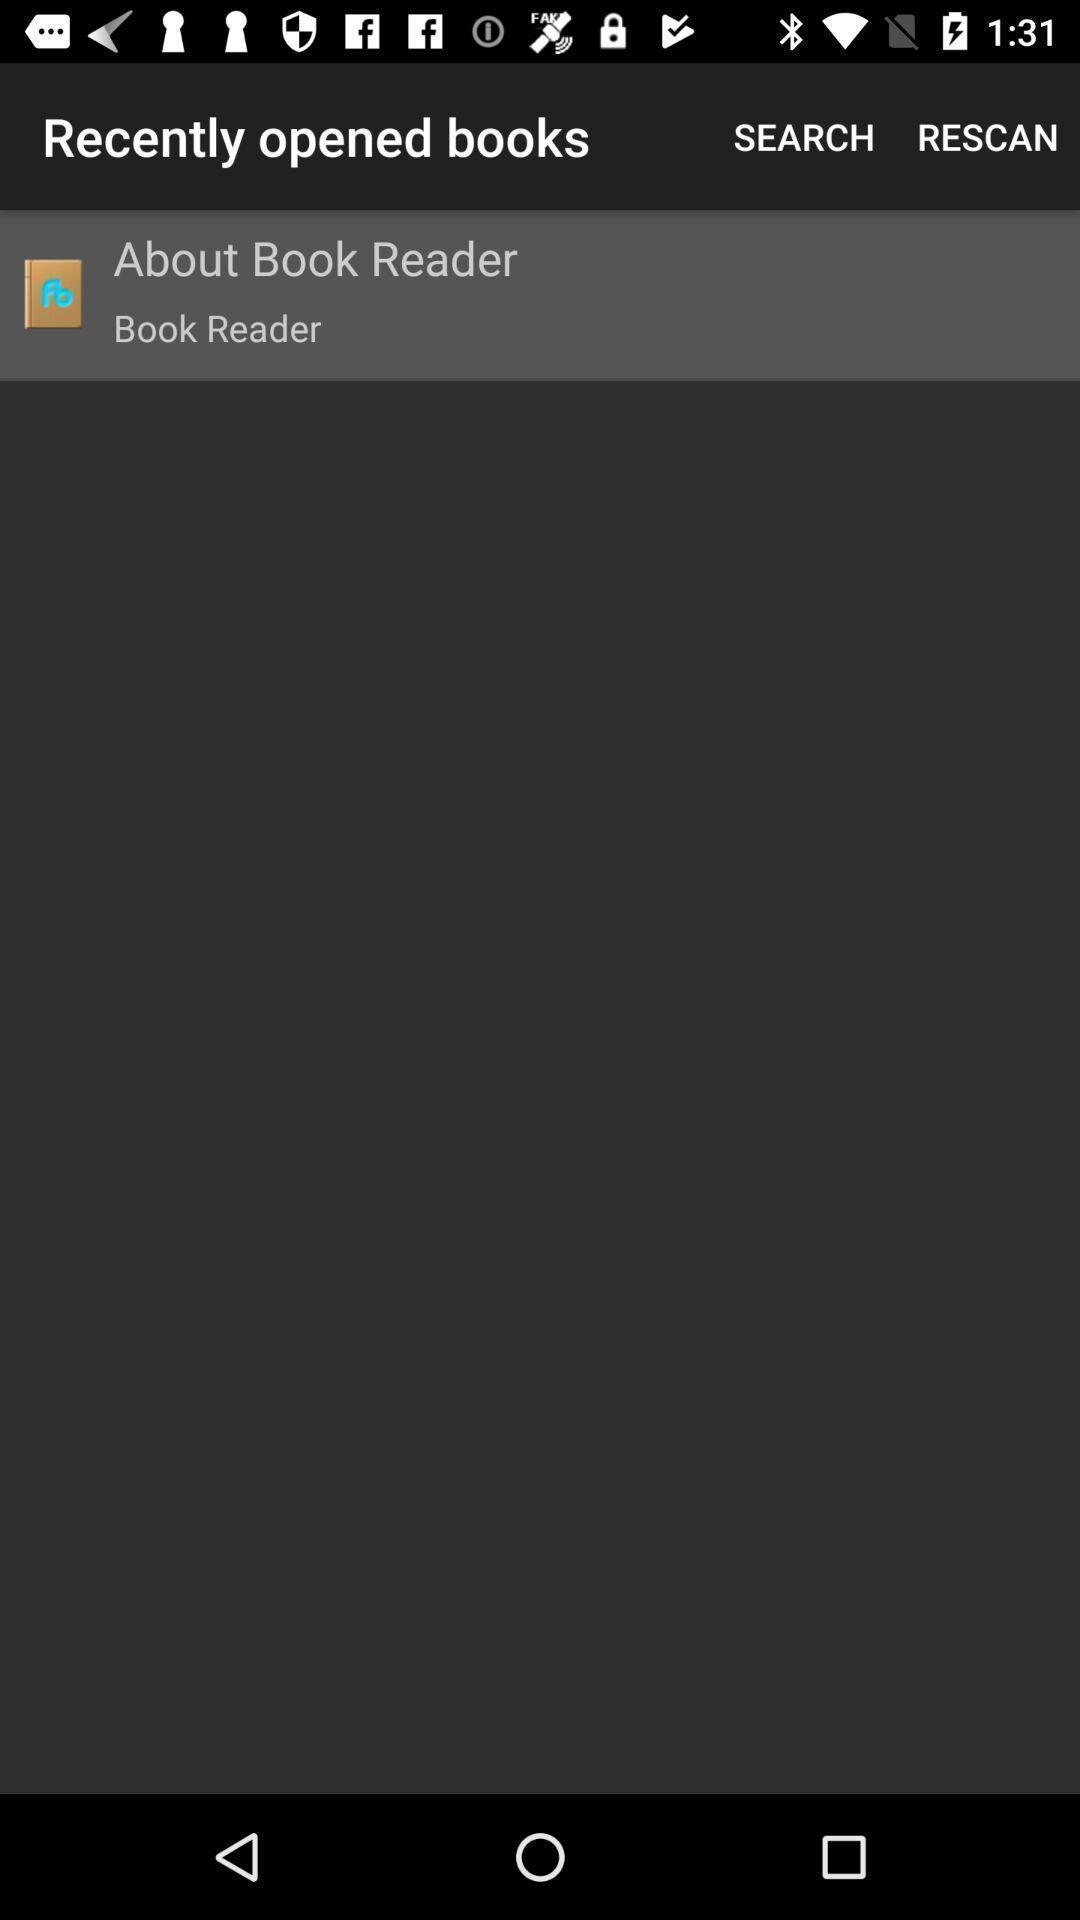Give me a narrative description of this picture. Page showing recently opened books. 